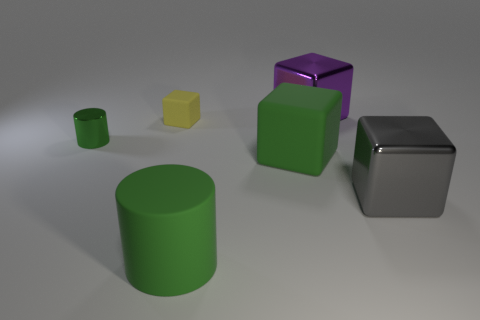Add 1 large blue matte cubes. How many objects exist? 7 Subtract all cubes. How many objects are left? 2 Subtract 0 cyan cylinders. How many objects are left? 6 Subtract all yellow matte things. Subtract all small green metal cylinders. How many objects are left? 4 Add 2 yellow rubber objects. How many yellow rubber objects are left? 3 Add 1 tiny green cylinders. How many tiny green cylinders exist? 2 